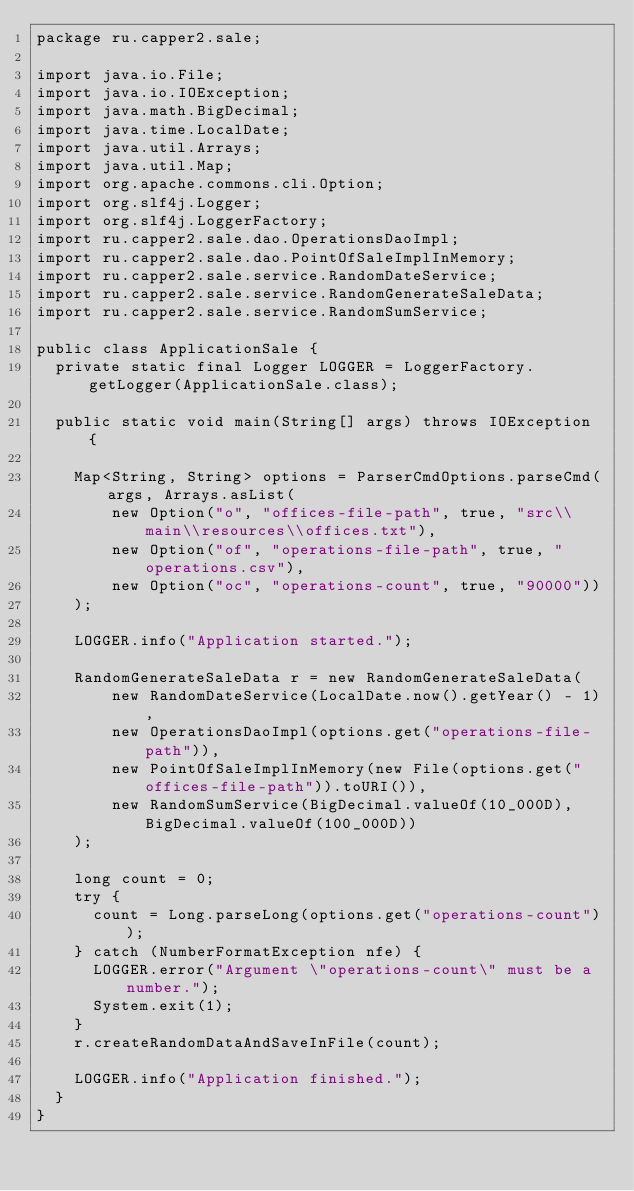Convert code to text. <code><loc_0><loc_0><loc_500><loc_500><_Java_>package ru.capper2.sale;

import java.io.File;
import java.io.IOException;
import java.math.BigDecimal;
import java.time.LocalDate;
import java.util.Arrays;
import java.util.Map;
import org.apache.commons.cli.Option;
import org.slf4j.Logger;
import org.slf4j.LoggerFactory;
import ru.capper2.sale.dao.OperationsDaoImpl;
import ru.capper2.sale.dao.PointOfSaleImplInMemory;
import ru.capper2.sale.service.RandomDateService;
import ru.capper2.sale.service.RandomGenerateSaleData;
import ru.capper2.sale.service.RandomSumService;

public class ApplicationSale {
  private static final Logger LOGGER = LoggerFactory.getLogger(ApplicationSale.class);

  public static void main(String[] args) throws IOException {

    Map<String, String> options = ParserCmdOptions.parseCmd(args, Arrays.asList(
        new Option("o", "offices-file-path", true, "src\\main\\resources\\offices.txt"),
        new Option("of", "operations-file-path", true, "operations.csv"),
        new Option("oc", "operations-count", true, "90000"))
    );

    LOGGER.info("Application started.");

    RandomGenerateSaleData r = new RandomGenerateSaleData(
        new RandomDateService(LocalDate.now().getYear() - 1),
        new OperationsDaoImpl(options.get("operations-file-path")),
        new PointOfSaleImplInMemory(new File(options.get("offices-file-path")).toURI()),
        new RandomSumService(BigDecimal.valueOf(10_000D), BigDecimal.valueOf(100_000D))
    );

    long count = 0;
    try {
      count = Long.parseLong(options.get("operations-count"));
    } catch (NumberFormatException nfe) {
      LOGGER.error("Argument \"operations-count\" must be a number.");
      System.exit(1);
    }
    r.createRandomDataAndSaveInFile(count);

    LOGGER.info("Application finished.");
  }
}
</code> 